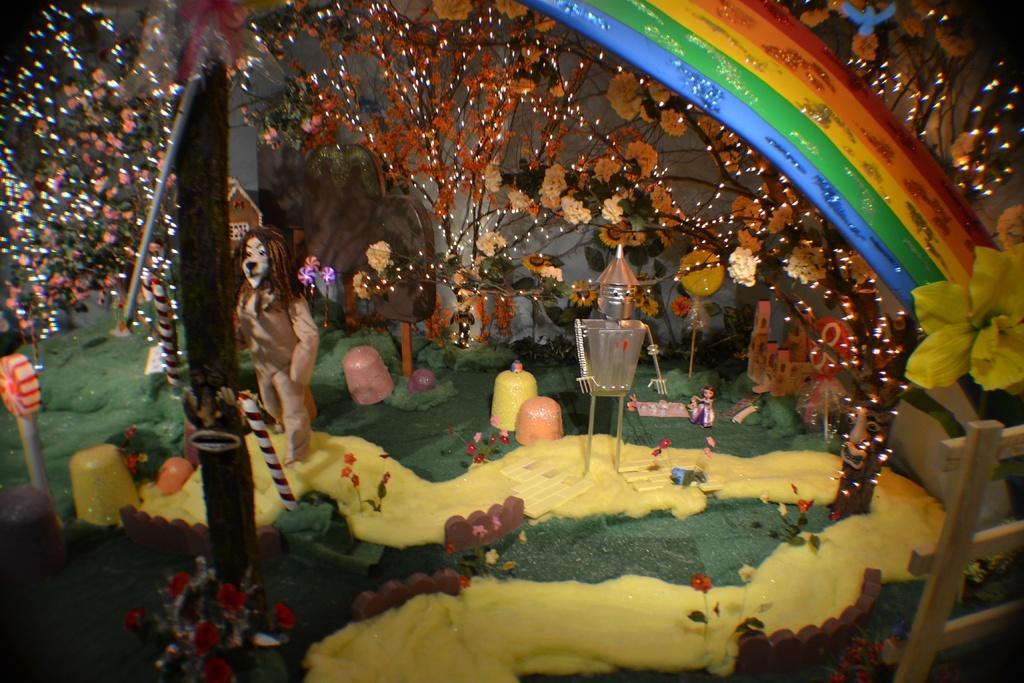Describe this image in one or two sentences. In this image, we can see a decorated room with some objects like toys, wood, flowers. We can also see some plants with lights. We can also see the rainbow. We can see the wall. We can see some grass. 